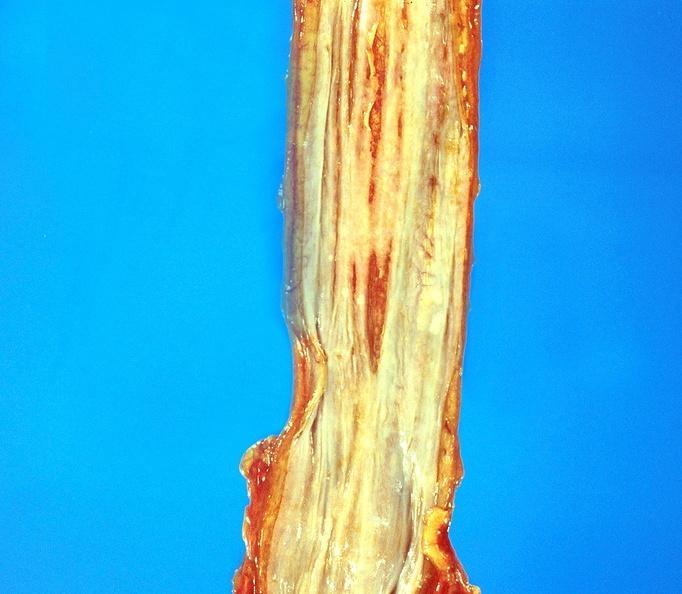s gastrointestinal present?
Answer the question using a single word or phrase. Yes 